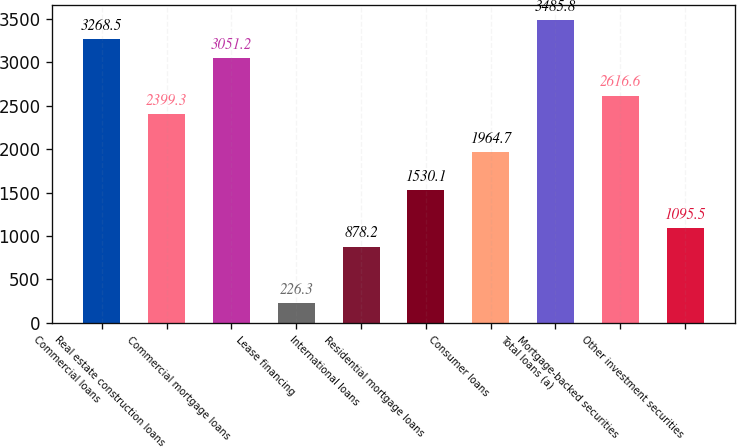Convert chart to OTSL. <chart><loc_0><loc_0><loc_500><loc_500><bar_chart><fcel>Commercial loans<fcel>Real estate construction loans<fcel>Commercial mortgage loans<fcel>Lease financing<fcel>International loans<fcel>Residential mortgage loans<fcel>Consumer loans<fcel>Total loans (a)<fcel>Mortgage-backed securities<fcel>Other investment securities<nl><fcel>3268.5<fcel>2399.3<fcel>3051.2<fcel>226.3<fcel>878.2<fcel>1530.1<fcel>1964.7<fcel>3485.8<fcel>2616.6<fcel>1095.5<nl></chart> 